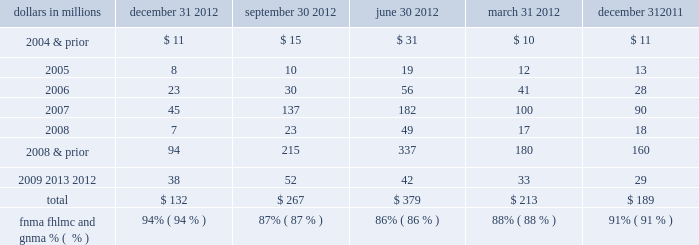Indemnification and repurchase claims are typically settled on an individual loan basis through make-whole payments or loan repurchases ; however , on occasion we may negotiate pooled settlements with investors .
In connection with pooled settlements , we typically do not repurchase loans and the consummation of such transactions generally results in us no longer having indemnification and repurchase exposure with the investor in the transaction .
For the first and second-lien mortgage balances of unresolved and settled claims contained in the tables below , a significant amount of these claims were associated with sold loans originated through correspondent lender and broker origination channels .
In certain instances when indemnification or repurchase claims are settled for these types of sold loans , we have recourse back to the correspondent lenders , brokers and other third-parties ( e.g. , contract underwriting companies , closing agents , appraisers , etc. ) .
Depending on the underlying reason for the investor claim , we determine our ability to pursue recourse with these parties and file claims with them accordingly .
Our historical recourse recovery rate has been insignificant as our efforts have been impacted by the inability of such parties to reimburse us for their recourse obligations ( e.g. , their capital availability or whether they remain in business ) or factors that limit our ability to pursue recourse from these parties ( e.g. , contractual loss caps , statutes of limitations ) .
Origination and sale of residential mortgages is an ongoing business activity , and , accordingly , management continually assesses the need to recognize indemnification and repurchase liabilities pursuant to the associated investor sale agreements .
We establish indemnification and repurchase liabilities for estimated losses on sold first and second-lien mortgages for which indemnification is expected to be provided or for loans that are expected to be repurchased .
For the first and second- lien mortgage sold portfolio , we have established an indemnification and repurchase liability pursuant to investor sale agreements based on claims made , demand patterns observed to date and/or expected in the future , and our estimate of future claims on a loan by loan basis .
To estimate the mortgage repurchase liability arising from breaches of representations and warranties , we consider the following factors : ( i ) borrower performance in our historically sold portfolio ( both actual and estimated future defaults ) , ( ii ) the level of outstanding unresolved repurchase claims , ( iii ) estimated probable future repurchase claims , considering information about file requests , delinquent and liquidated loans , resolved and unresolved mortgage insurance rescission notices and our historical experience with claim rescissions , ( iv ) the potential ability to cure the defects identified in the repurchase claims ( 201crescission rate 201d ) , and ( v ) the estimated severity of loss upon repurchase of the loan or collateral , make-whole settlement , or indemnification .
See note 24 commitments and guarantees in the notes to consolidated financial statements in item 8 of this report for additional information .
The tables present the unpaid principal balance of repurchase claims by vintage and total unresolved repurchase claims for the past five quarters .
Table 28 : analysis of quarterly residential mortgage repurchase claims by vintage dollars in millions december 31 september 30 june 30 march 31 december 31 .
The pnc financial services group , inc .
2013 form 10-k 79 .
For 2012 quarterly residential mortgage repurchase claims , what was the change in millions between originations from first and second quarter of 2007? 
Computations: (100 - 90)
Answer: 10.0. Indemnification and repurchase claims are typically settled on an individual loan basis through make-whole payments or loan repurchases ; however , on occasion we may negotiate pooled settlements with investors .
In connection with pooled settlements , we typically do not repurchase loans and the consummation of such transactions generally results in us no longer having indemnification and repurchase exposure with the investor in the transaction .
For the first and second-lien mortgage balances of unresolved and settled claims contained in the tables below , a significant amount of these claims were associated with sold loans originated through correspondent lender and broker origination channels .
In certain instances when indemnification or repurchase claims are settled for these types of sold loans , we have recourse back to the correspondent lenders , brokers and other third-parties ( e.g. , contract underwriting companies , closing agents , appraisers , etc. ) .
Depending on the underlying reason for the investor claim , we determine our ability to pursue recourse with these parties and file claims with them accordingly .
Our historical recourse recovery rate has been insignificant as our efforts have been impacted by the inability of such parties to reimburse us for their recourse obligations ( e.g. , their capital availability or whether they remain in business ) or factors that limit our ability to pursue recourse from these parties ( e.g. , contractual loss caps , statutes of limitations ) .
Origination and sale of residential mortgages is an ongoing business activity , and , accordingly , management continually assesses the need to recognize indemnification and repurchase liabilities pursuant to the associated investor sale agreements .
We establish indemnification and repurchase liabilities for estimated losses on sold first and second-lien mortgages for which indemnification is expected to be provided or for loans that are expected to be repurchased .
For the first and second- lien mortgage sold portfolio , we have established an indemnification and repurchase liability pursuant to investor sale agreements based on claims made , demand patterns observed to date and/or expected in the future , and our estimate of future claims on a loan by loan basis .
To estimate the mortgage repurchase liability arising from breaches of representations and warranties , we consider the following factors : ( i ) borrower performance in our historically sold portfolio ( both actual and estimated future defaults ) , ( ii ) the level of outstanding unresolved repurchase claims , ( iii ) estimated probable future repurchase claims , considering information about file requests , delinquent and liquidated loans , resolved and unresolved mortgage insurance rescission notices and our historical experience with claim rescissions , ( iv ) the potential ability to cure the defects identified in the repurchase claims ( 201crescission rate 201d ) , and ( v ) the estimated severity of loss upon repurchase of the loan or collateral , make-whole settlement , or indemnification .
See note 24 commitments and guarantees in the notes to consolidated financial statements in item 8 of this report for additional information .
The tables present the unpaid principal balance of repurchase claims by vintage and total unresolved repurchase claims for the past five quarters .
Table 28 : analysis of quarterly residential mortgage repurchase claims by vintage dollars in millions december 31 september 30 june 30 march 31 december 31 .
The pnc financial services group , inc .
2013 form 10-k 79 .
By what percentage did the amount of claims as of sept 30 , 2007 decrease to equal the combined claims september 30 of 2009-2012? 
Computations: (((137 - 52) / 137) * 100)
Answer: 62.0438. Indemnification and repurchase claims are typically settled on an individual loan basis through make-whole payments or loan repurchases ; however , on occasion we may negotiate pooled settlements with investors .
In connection with pooled settlements , we typically do not repurchase loans and the consummation of such transactions generally results in us no longer having indemnification and repurchase exposure with the investor in the transaction .
For the first and second-lien mortgage balances of unresolved and settled claims contained in the tables below , a significant amount of these claims were associated with sold loans originated through correspondent lender and broker origination channels .
In certain instances when indemnification or repurchase claims are settled for these types of sold loans , we have recourse back to the correspondent lenders , brokers and other third-parties ( e.g. , contract underwriting companies , closing agents , appraisers , etc. ) .
Depending on the underlying reason for the investor claim , we determine our ability to pursue recourse with these parties and file claims with them accordingly .
Our historical recourse recovery rate has been insignificant as our efforts have been impacted by the inability of such parties to reimburse us for their recourse obligations ( e.g. , their capital availability or whether they remain in business ) or factors that limit our ability to pursue recourse from these parties ( e.g. , contractual loss caps , statutes of limitations ) .
Origination and sale of residential mortgages is an ongoing business activity , and , accordingly , management continually assesses the need to recognize indemnification and repurchase liabilities pursuant to the associated investor sale agreements .
We establish indemnification and repurchase liabilities for estimated losses on sold first and second-lien mortgages for which indemnification is expected to be provided or for loans that are expected to be repurchased .
For the first and second- lien mortgage sold portfolio , we have established an indemnification and repurchase liability pursuant to investor sale agreements based on claims made , demand patterns observed to date and/or expected in the future , and our estimate of future claims on a loan by loan basis .
To estimate the mortgage repurchase liability arising from breaches of representations and warranties , we consider the following factors : ( i ) borrower performance in our historically sold portfolio ( both actual and estimated future defaults ) , ( ii ) the level of outstanding unresolved repurchase claims , ( iii ) estimated probable future repurchase claims , considering information about file requests , delinquent and liquidated loans , resolved and unresolved mortgage insurance rescission notices and our historical experience with claim rescissions , ( iv ) the potential ability to cure the defects identified in the repurchase claims ( 201crescission rate 201d ) , and ( v ) the estimated severity of loss upon repurchase of the loan or collateral , make-whole settlement , or indemnification .
See note 24 commitments and guarantees in the notes to consolidated financial statements in item 8 of this report for additional information .
The tables present the unpaid principal balance of repurchase claims by vintage and total unresolved repurchase claims for the past five quarters .
Table 28 : analysis of quarterly residential mortgage repurchase claims by vintage dollars in millions december 31 september 30 june 30 march 31 december 31 .
The pnc financial services group , inc .
2013 form 10-k 79 .
For 2012 quarterly residential mortgage repurchase claims , what was the change in millions between originations from first and second quarter of 2006? 
Computations: (41 - 28)
Answer: 13.0. 